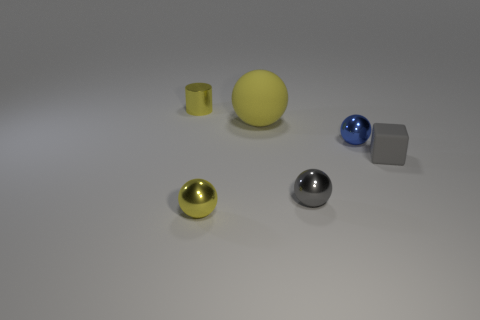Add 1 small red things. How many objects exist? 7 Subtract all matte balls. How many balls are left? 3 Subtract 1 blocks. How many blocks are left? 0 Subtract all balls. How many objects are left? 2 Subtract all red cylinders. Subtract all brown spheres. How many cylinders are left? 1 Subtract all blue cubes. How many blue spheres are left? 1 Subtract all blue cylinders. Subtract all blue objects. How many objects are left? 5 Add 2 rubber cubes. How many rubber cubes are left? 3 Add 4 tiny green metallic cubes. How many tiny green metallic cubes exist? 4 Subtract all blue balls. How many balls are left? 3 